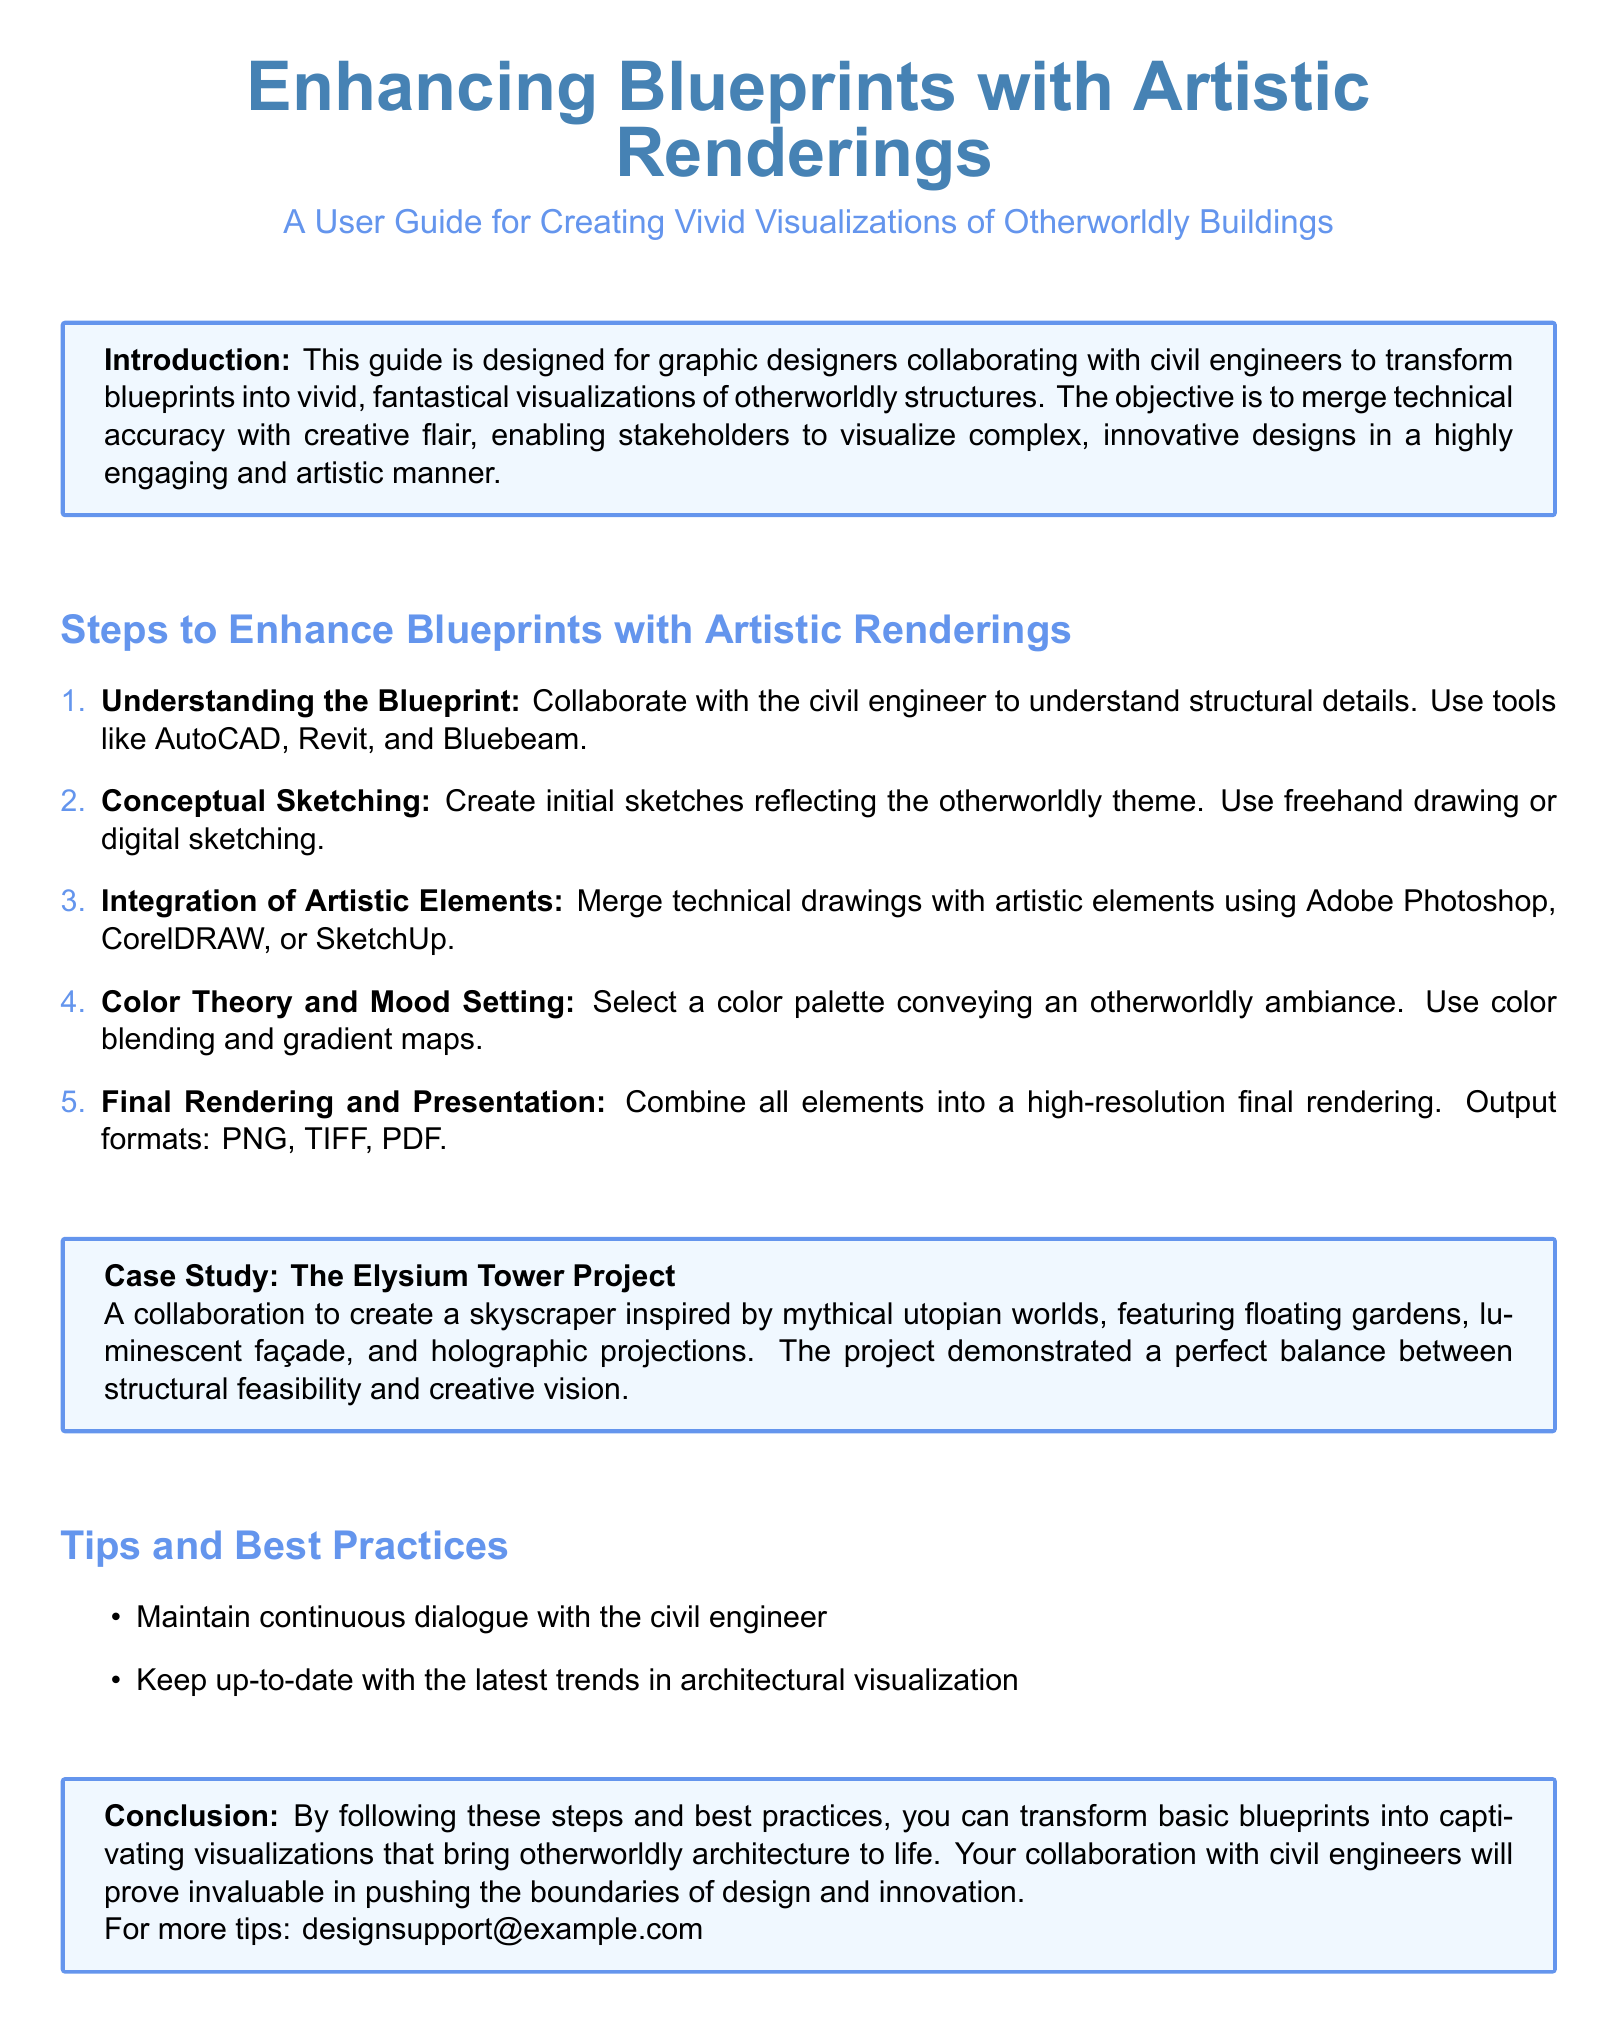What is the main focus of the guide? The guide is designed for graphic designers collaborating with civil engineers to enhance blueprints into vivid visualizations.
Answer: Enhance blueprints into vivid visualizations How many steps are outlined for enhancing blueprints? The document lists five specific steps for enhancing blueprints with artistic renderings.
Answer: Five Which software is suggested for integrating artistic elements? The document recommends using Adobe Photoshop, CorelDRAW, or SketchUp for merging technical drawings with artistic elements.
Answer: Adobe Photoshop, CorelDRAW, SketchUp What is the color palette used to convey an ambiance? The guide emphasizes selecting a color palette that conveys an otherworldly ambiance as part of the artistic rendering process.
Answer: Otherworldly ambiance Who should maintain continuous dialogue according to the best practices? The best practice stated in the document advises maintaining continuous dialogue with the civil engineer throughout the design process.
Answer: Civil engineer 